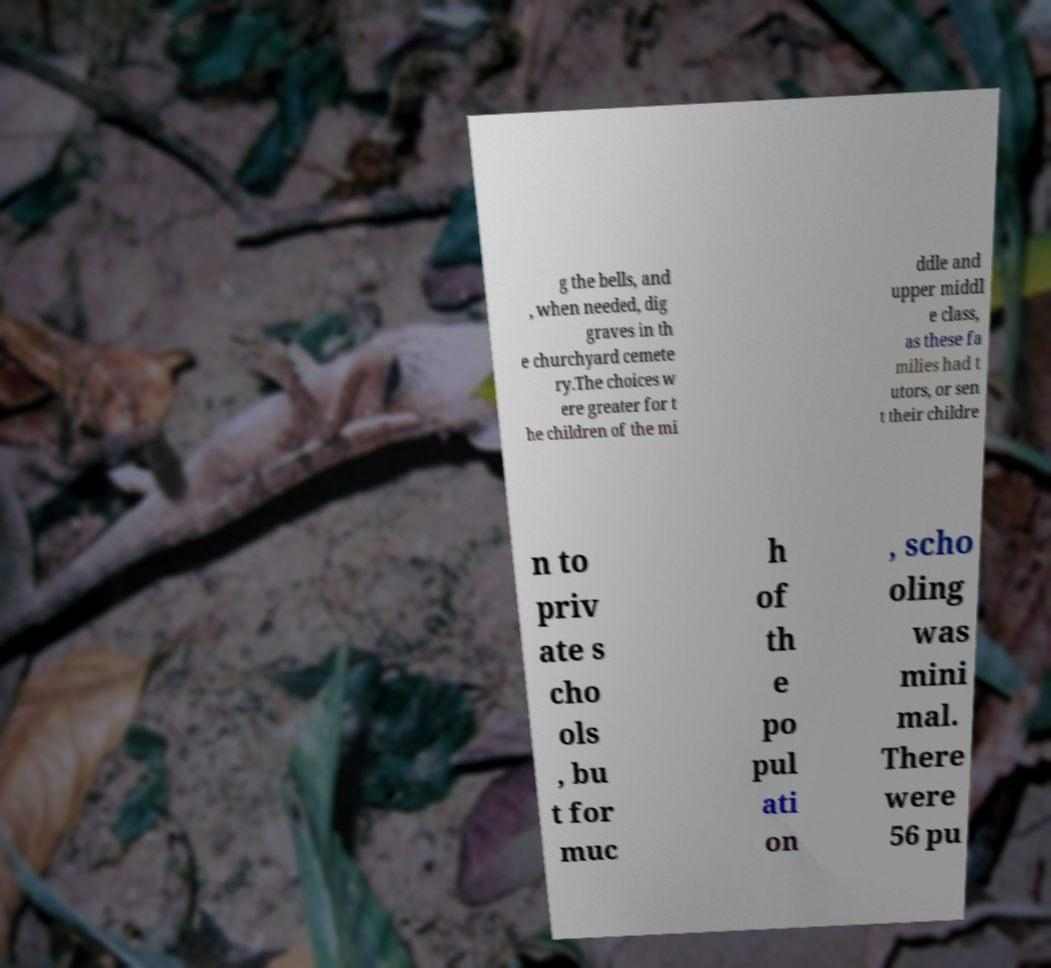I need the written content from this picture converted into text. Can you do that? g the bells, and , when needed, dig graves in th e churchyard cemete ry.The choices w ere greater for t he children of the mi ddle and upper middl e class, as these fa milies had t utors, or sen t their childre n to priv ate s cho ols , bu t for muc h of th e po pul ati on , scho oling was mini mal. There were 56 pu 